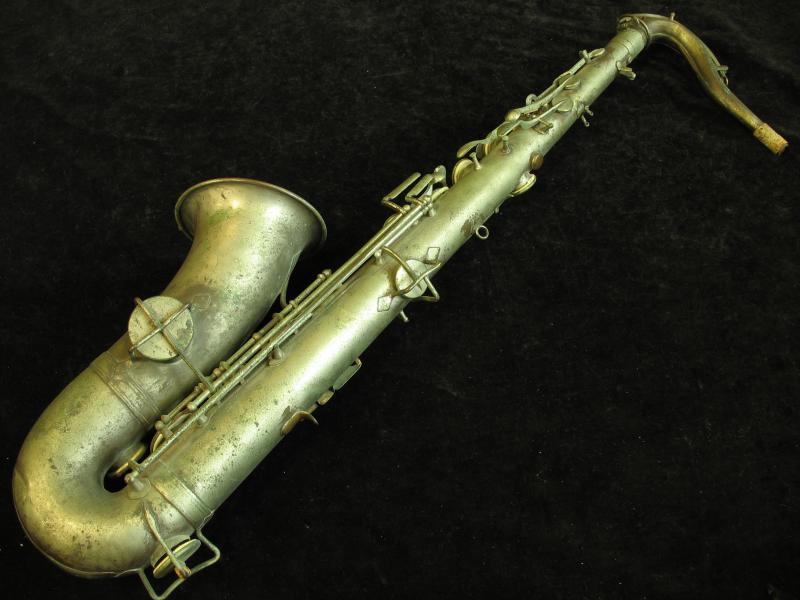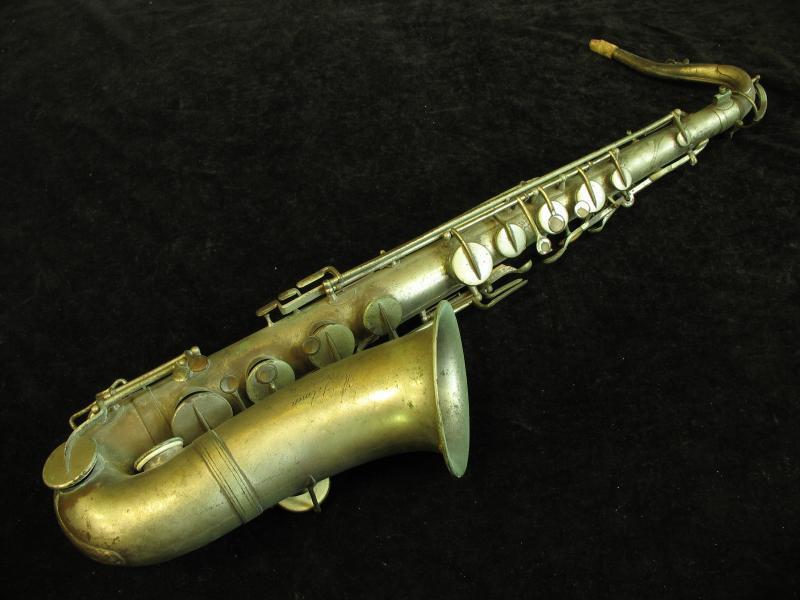The first image is the image on the left, the second image is the image on the right. Analyze the images presented: Is the assertion "The instrument in the image on the right is badly tarnished." valid? Answer yes or no. Yes. 